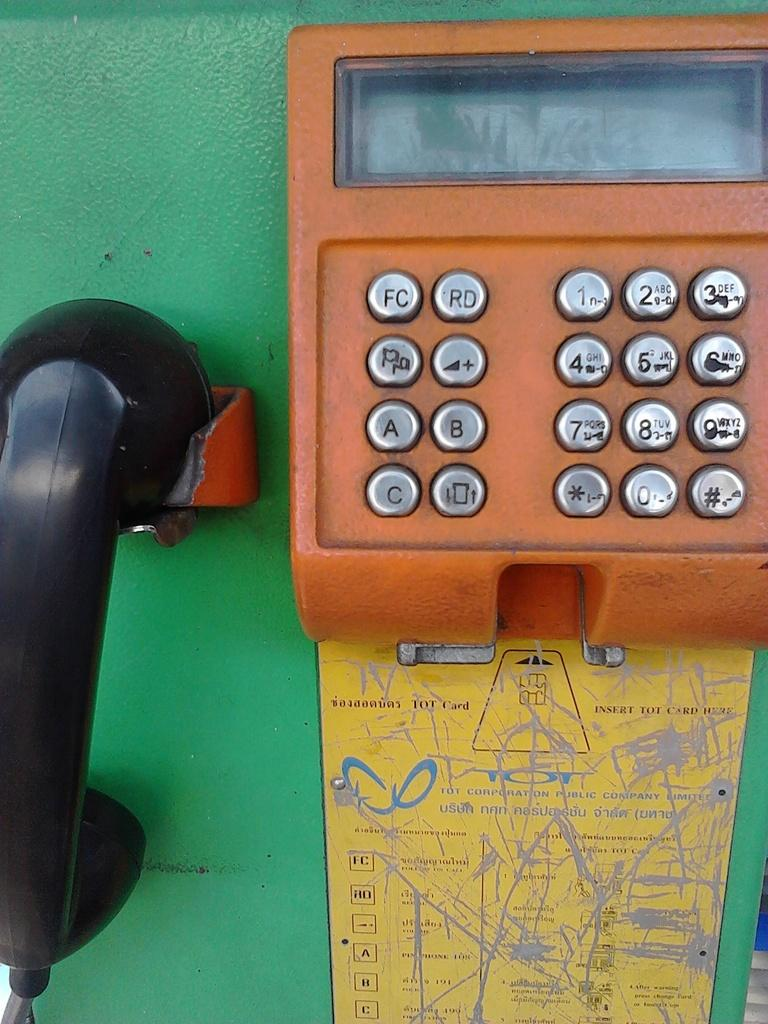What object can be seen in the image? There is a telephone in the image. What colors are present on the telephone? The telephone has green and orange colors. Where is the glove placed in the image? There is no glove present in the image. What type of wilderness can be seen in the background of the image? There is no wilderness visible in the image; it only features a telephone. 